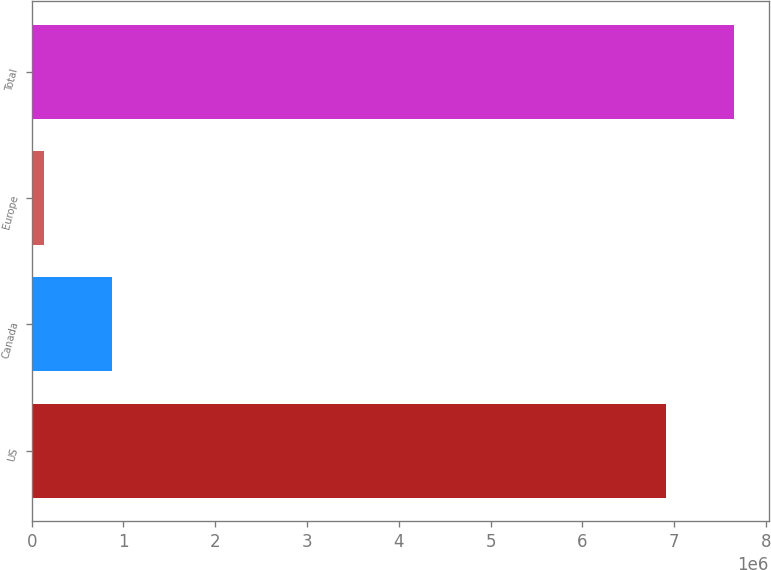Convert chart. <chart><loc_0><loc_0><loc_500><loc_500><bar_chart><fcel>US<fcel>Canada<fcel>Europe<fcel>Total<nl><fcel>6.91412e+06<fcel>872778<fcel>139106<fcel>7.64779e+06<nl></chart> 